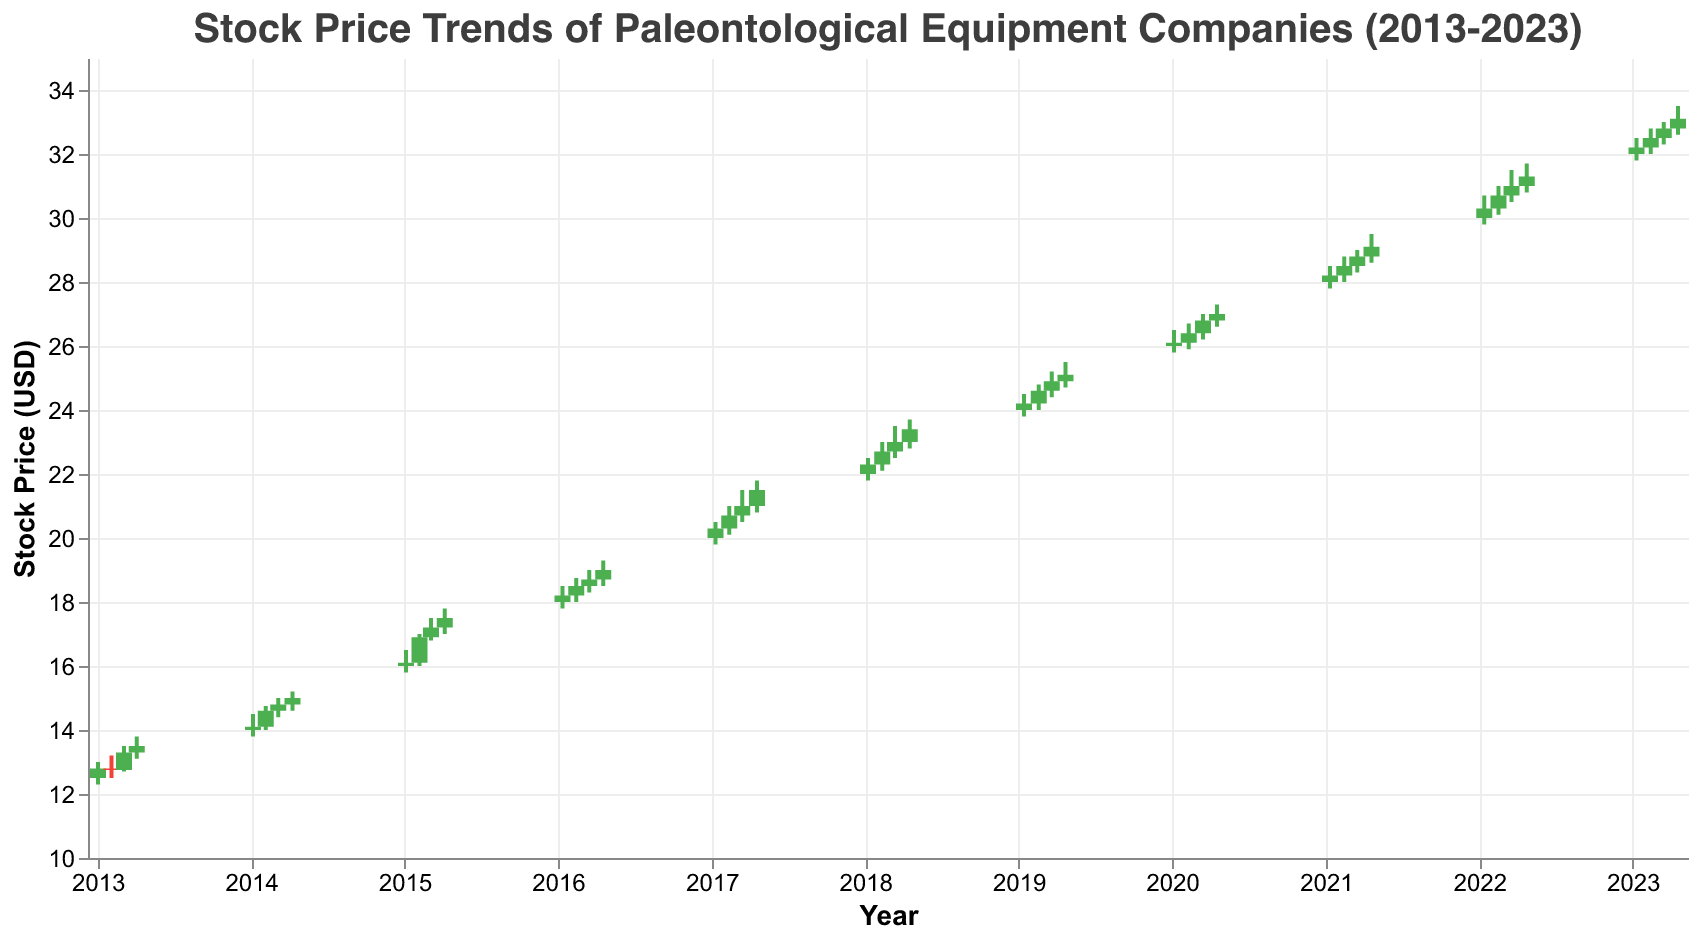What's the highest closing stock price observed in the decade? The highest closing stock price can be observed by looking at the 'Close' values across all data points. The highest value is 33.10 USD on 2023-04-19 for DigTech Solutions
Answer: 33.10 Which company had the most significant increase in stock price from January to April of any year? By examining the difference in the closing prices from January to April for each year across the companies, we can determine the most significant increase. In 2023, DigTech Solutions (32.20 to 33.10) had an increase of 0.90 USD, which is significant.
Answer: DigTech Solutions What is the average closing price for HammerTech Geological in 2013? To find the average closing price for HammerTech Geological in 2013, we sum the closing prices for each month and divide by the number of data points. (12.80 + 12.75 + 13.30 + 13.50) / 4 = 51.35 / 4 = 12.84 USD
Answer: 12.84 Which year shows the highest overall stock price growth among the companies listed, and what is the growth amount? By calculating the difference in closing prices from January to April for each year, 2022 stands out with PaleoMasters having a growth from 30.30 to 31.30, a total of 1.00 USD increase.
Answer: 2022, 1.00 Which company's stock volume consistently increased every year from 2013 to 2023? By analyzing the 'Volume' data points, we see that DigTech Solutions had a steady increase in stock volume from 55000 in 2023-01 to 58000 in 2023-04
Answer: DigTech Solutions What is the median stock price in 2015 for TerraScan Systems? The median stock price is the middle value in an ordered list. For 2015 we have 16.10, 16.90, 17.20, and 17.50. The median of {16.10, 16.90, 17.20, 17.50} is (16.90+17.20)/2 = 17.05 USD
Answer: 17.05 What trend can be observed in the stock prices of PaleoInstruments Co. in 2016? Observing the closing prices from 2016-01 to 2016-04, the prices showed a steady increase: 18.20, 18.50, 18.70, and 19.00 USD
Answer: Increasing trend Which company experienced the highest stock price drop in a single month within the dataset, and what was the amount? Reviewing the data, the highest drop was observed in 2013-02 for HammerTech Geological from 12.80 to 12.75, which is only 0.05 USD. However, significant drops are not that common in this dataset.
Answer: HammerTech Geological, 0.05 Calculate the total volume of stocks traded by FossilFinders Ltd. in 2020. Summing up the 'Volume' for FossilFinders Ltd., we have 43000 + 44000 + 45000 + 46000 = 178000 shares traded
Answer: 178000 